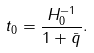<formula> <loc_0><loc_0><loc_500><loc_500>t _ { 0 } = \frac { H _ { 0 } ^ { - 1 } } { 1 + { \bar { q } } } .</formula> 